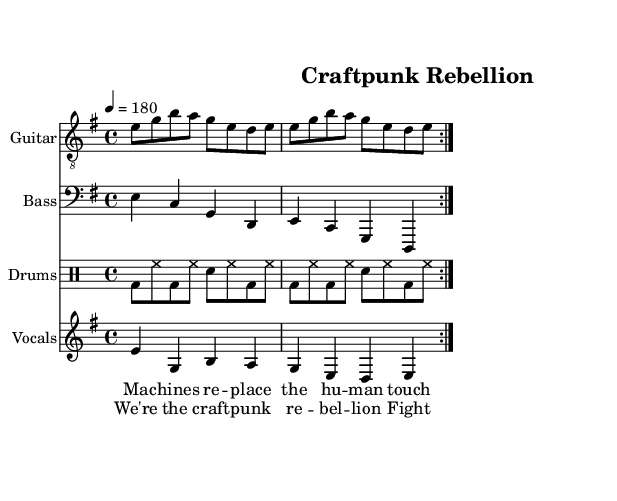What is the key signature of this music? The key signature is E minor, which includes one sharp (F#). This can be determined by looking at the beginning of the score where the key signature is indicated.
Answer: E minor What is the time signature of this piece? The time signature is 4/4, as indicated in the score. This means there are four beats in each measure, and a quarter note receives one beat.
Answer: 4/4 What is the tempo marking for this composition? The piece is marked with a tempo of 180 beats per minute. This is shown at the beginning of the score as '4 = 180'.
Answer: 180 How many times do the verses repeat in the lyrics? The lyrics for the verse are indicated to repeat twice as shown by the "repeat volta 2" notation in the score. This means each verse section will be sung two times.
Answer: 2 What is the main theme of the lyrics? The lyrics critique the impact of machines on traditional craftsmanship and emphasize a rebellion for creation, reflecting a punk ethos that values artisanal skills. This theme is captured in the phrases used in the verse and chorus.
Answer: Craftpunk rebellion What instruments are used in this composition? The composition features guitar, bass, and drums, which are typically found in punk music. Each instrument is notated in its own staff within the score.
Answer: Guitar, Bass, Drums What is the lyrical message conveyed in the chorus? The chorus emphasizes rebellion and a fight for creativity, highlighting the desire to preserve traditional crafting skills against modern mechanization. This encapsulates the spirit of punk music as a form of protest and self-expression.
Answer: Fighting for creation 